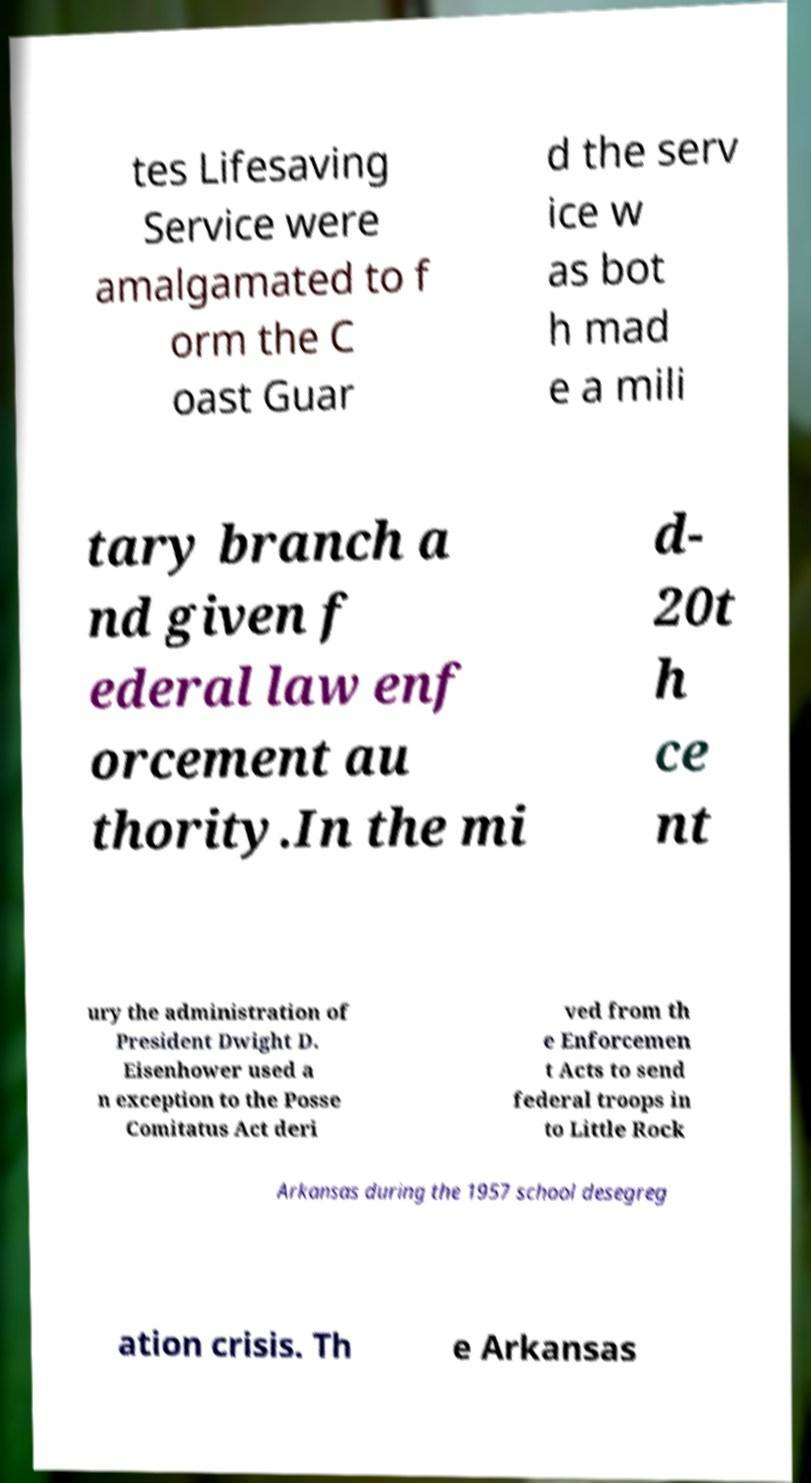Please read and relay the text visible in this image. What does it say? tes Lifesaving Service were amalgamated to f orm the C oast Guar d the serv ice w as bot h mad e a mili tary branch a nd given f ederal law enf orcement au thority.In the mi d- 20t h ce nt ury the administration of President Dwight D. Eisenhower used a n exception to the Posse Comitatus Act deri ved from th e Enforcemen t Acts to send federal troops in to Little Rock Arkansas during the 1957 school desegreg ation crisis. Th e Arkansas 